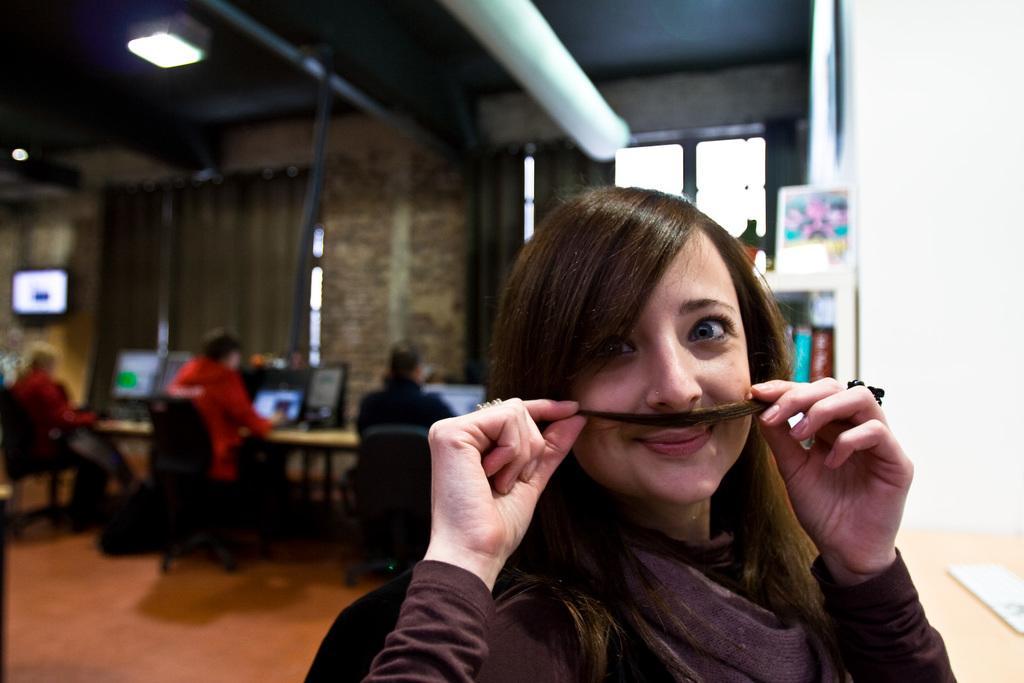Please provide a concise description of this image. In this image there is a woman sitting on the chair. Left side few people are sitting on the chair. Before them there is a table having monitors and laptops. Background there is a wall having a window. A light is attached to the roof. 